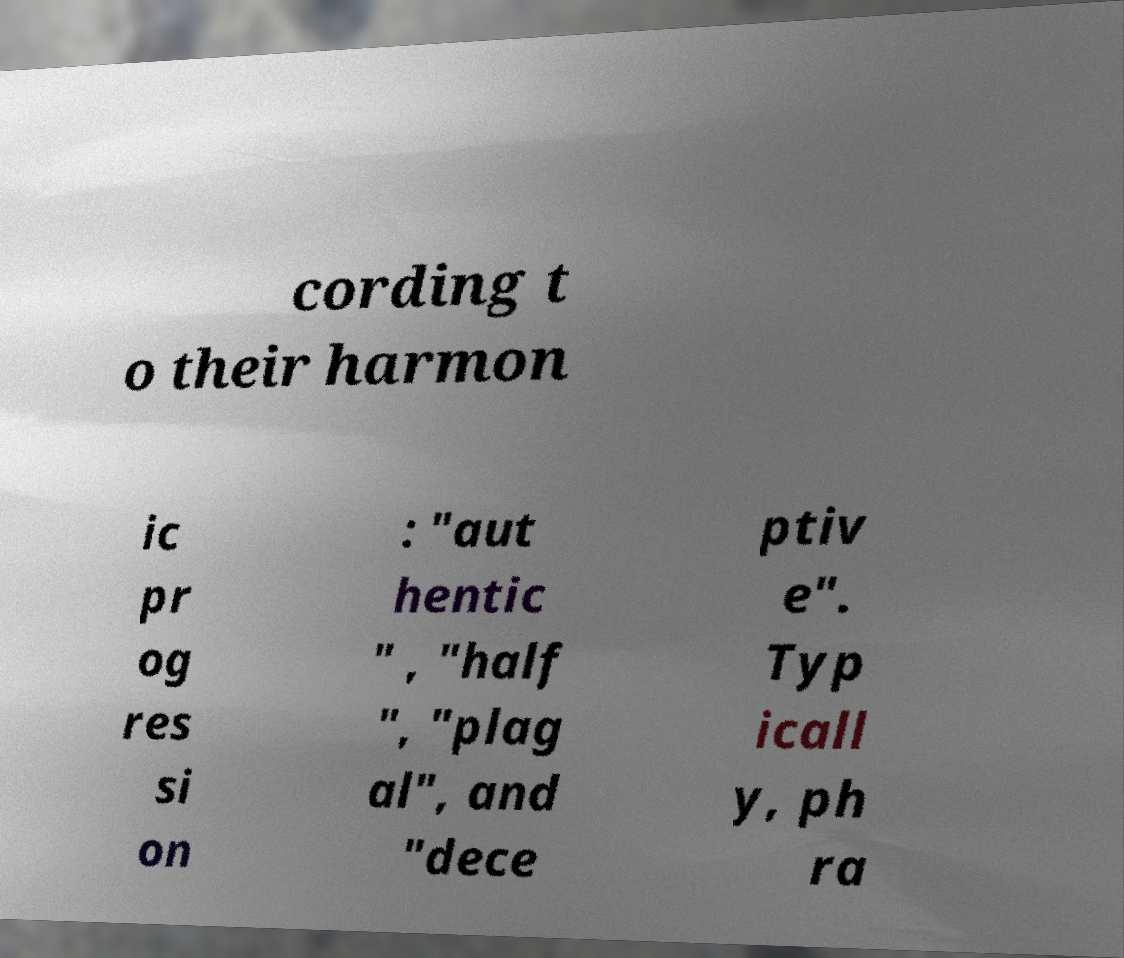There's text embedded in this image that I need extracted. Can you transcribe it verbatim? cording t o their harmon ic pr og res si on : "aut hentic " , "half ", "plag al", and "dece ptiv e". Typ icall y, ph ra 